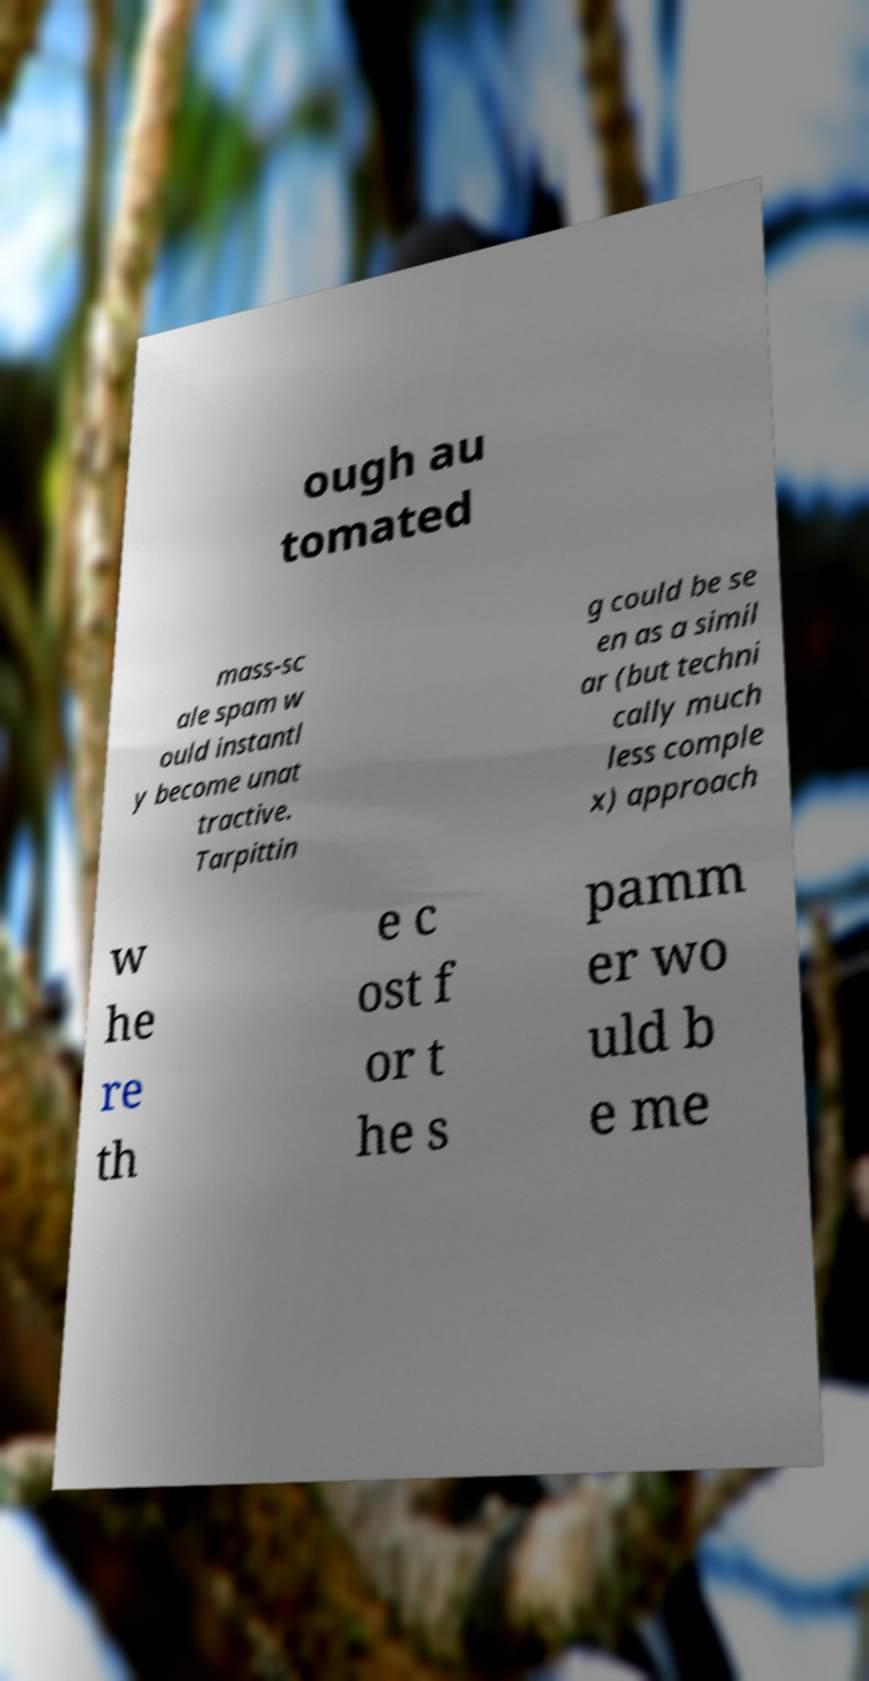Could you assist in decoding the text presented in this image and type it out clearly? ough au tomated mass-sc ale spam w ould instantl y become unat tractive. Tarpittin g could be se en as a simil ar (but techni cally much less comple x) approach w he re th e c ost f or t he s pamm er wo uld b e me 